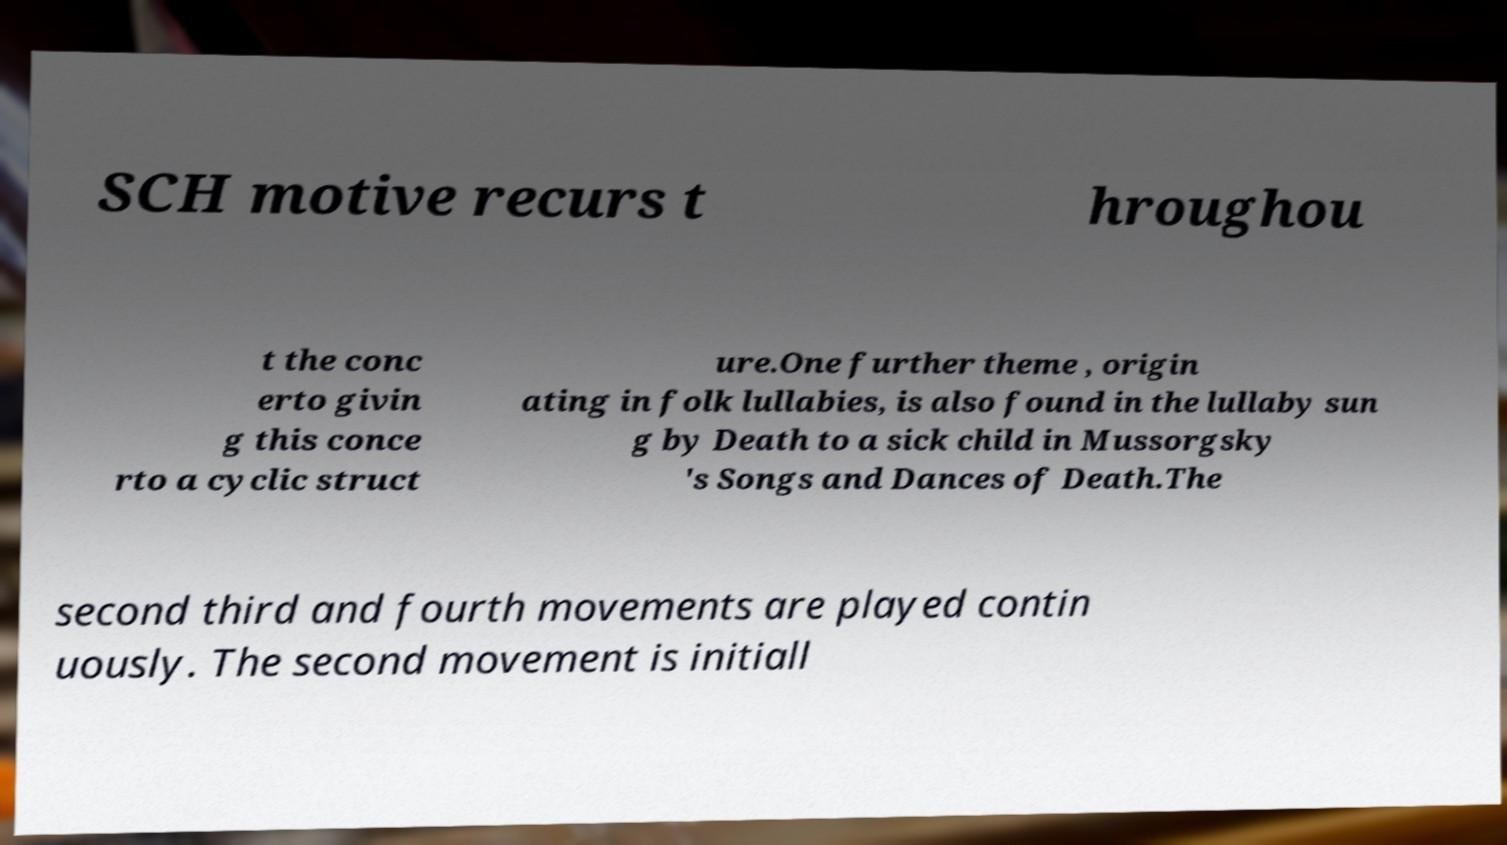Can you accurately transcribe the text from the provided image for me? SCH motive recurs t hroughou t the conc erto givin g this conce rto a cyclic struct ure.One further theme , origin ating in folk lullabies, is also found in the lullaby sun g by Death to a sick child in Mussorgsky 's Songs and Dances of Death.The second third and fourth movements are played contin uously. The second movement is initiall 